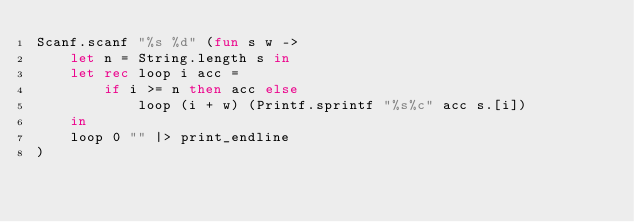Convert code to text. <code><loc_0><loc_0><loc_500><loc_500><_OCaml_>Scanf.scanf "%s %d" (fun s w ->
    let n = String.length s in
    let rec loop i acc =
        if i >= n then acc else
            loop (i + w) (Printf.sprintf "%s%c" acc s.[i])
    in
    loop 0 "" |> print_endline
)</code> 